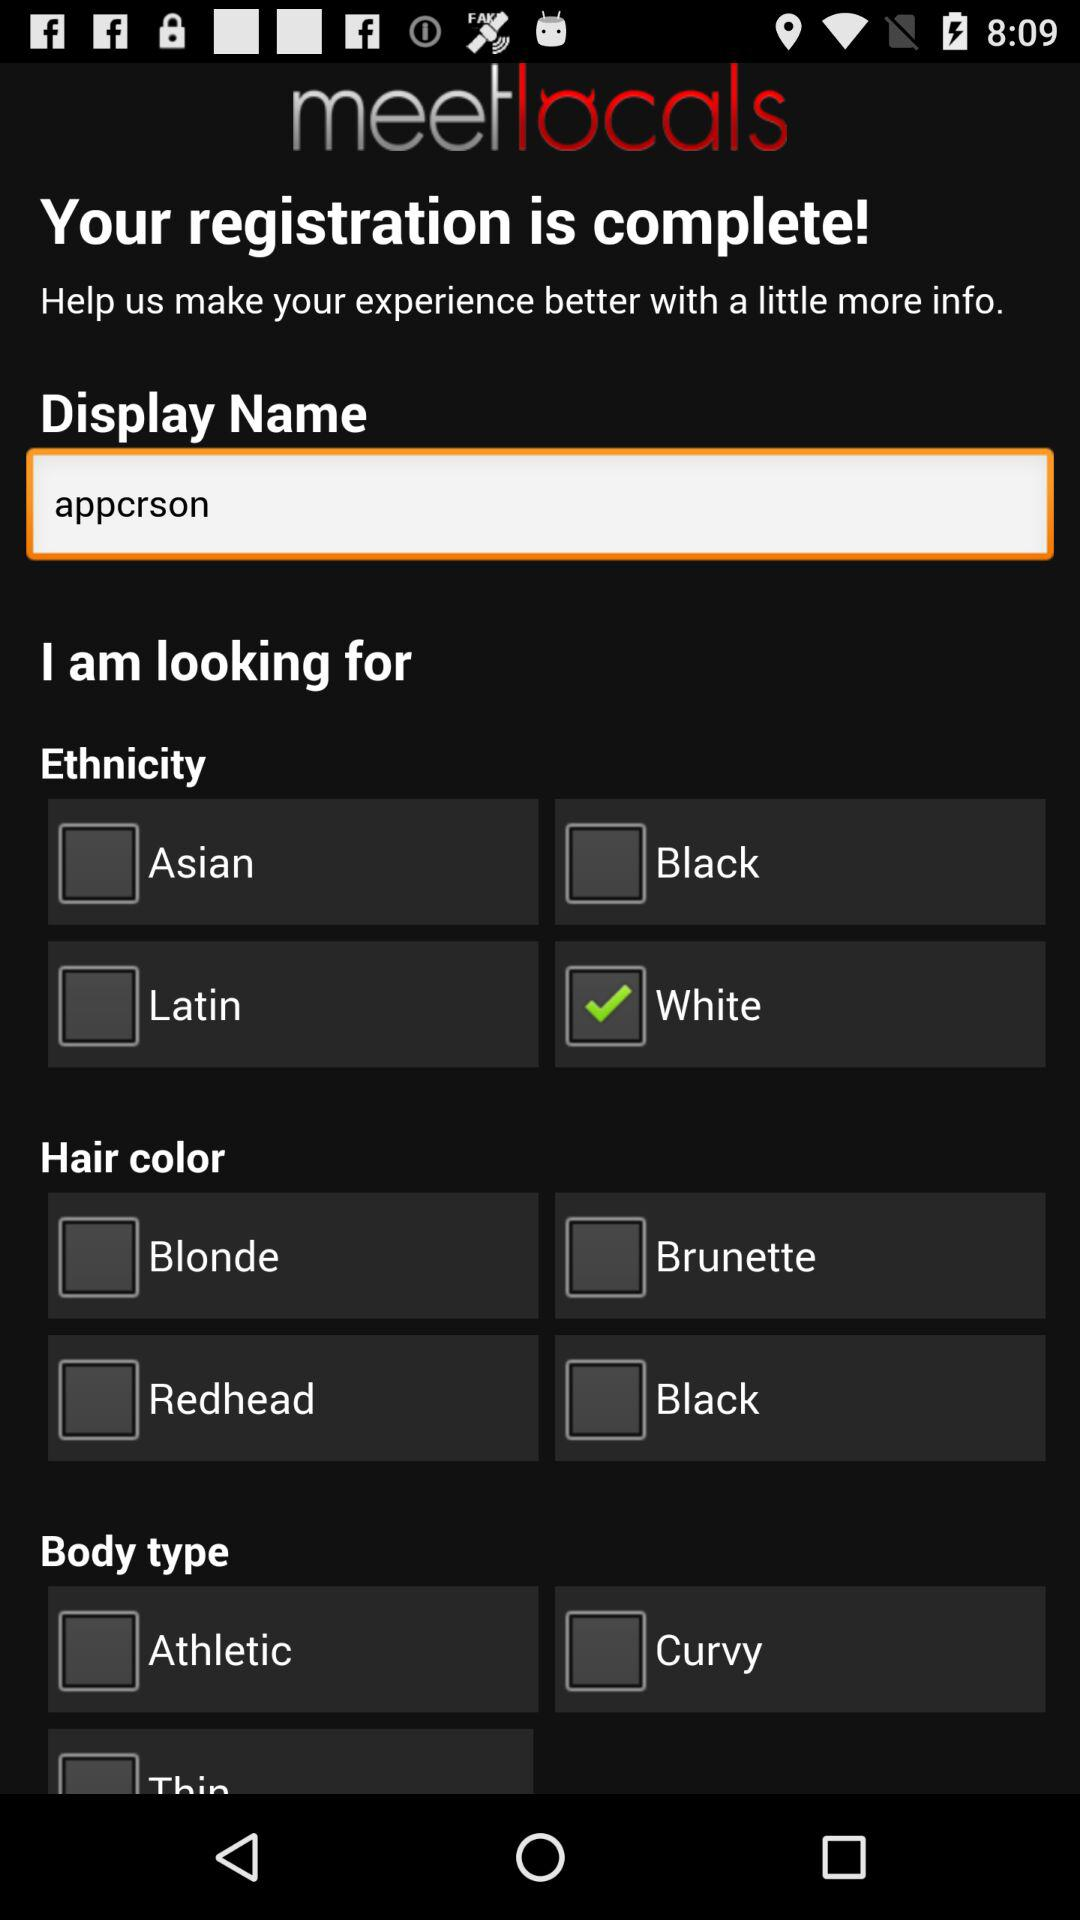What is the status of "Curvy"? The status of "Curvy" is "off". 